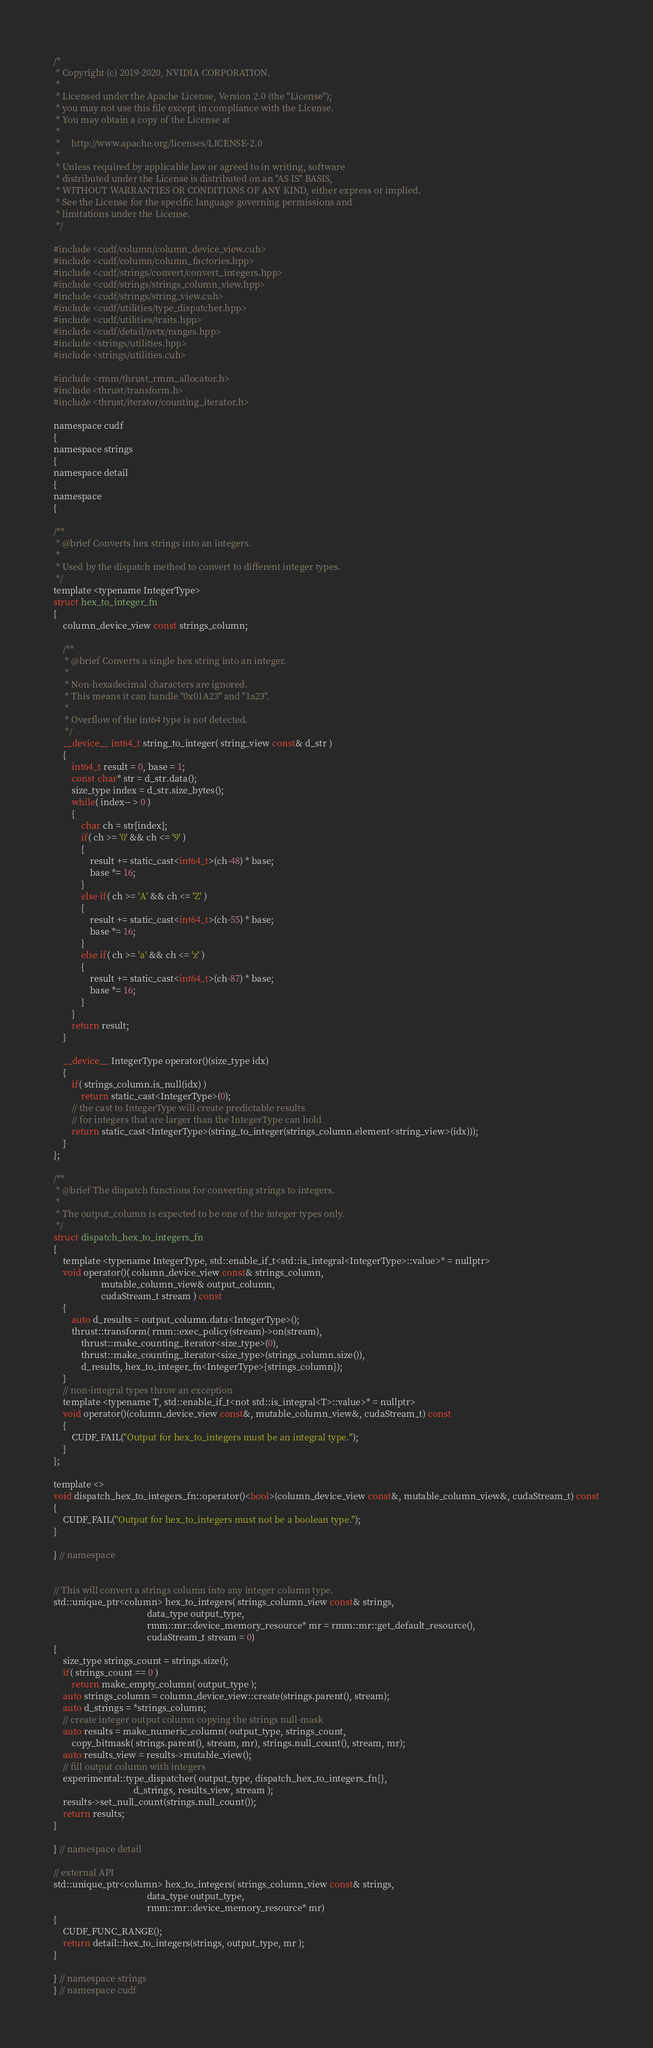<code> <loc_0><loc_0><loc_500><loc_500><_Cuda_>/*
 * Copyright (c) 2019-2020, NVIDIA CORPORATION.
 *
 * Licensed under the Apache License, Version 2.0 (the "License");
 * you may not use this file except in compliance with the License.
 * You may obtain a copy of the License at
 *
 *     http://www.apache.org/licenses/LICENSE-2.0
 *
 * Unless required by applicable law or agreed to in writing, software
 * distributed under the License is distributed on an "AS IS" BASIS,
 * WITHOUT WARRANTIES OR CONDITIONS OF ANY KIND, either express or implied.
 * See the License for the specific language governing permissions and
 * limitations under the License.
 */

#include <cudf/column/column_device_view.cuh>
#include <cudf/column/column_factories.hpp>
#include <cudf/strings/convert/convert_integers.hpp>
#include <cudf/strings/strings_column_view.hpp>
#include <cudf/strings/string_view.cuh>
#include <cudf/utilities/type_dispatcher.hpp>
#include <cudf/utilities/traits.hpp>
#include <cudf/detail/nvtx/ranges.hpp>
#include <strings/utilities.hpp>
#include <strings/utilities.cuh>

#include <rmm/thrust_rmm_allocator.h>
#include <thrust/transform.h>
#include <thrust/iterator/counting_iterator.h>

namespace cudf
{
namespace strings
{
namespace detail
{
namespace
{

/**
 * @brief Converts hex strings into an integers.
 *
 * Used by the dispatch method to convert to different integer types.
 */
template <typename IntegerType>
struct hex_to_integer_fn
{
    column_device_view const strings_column;

    /**
     * @brief Converts a single hex string into an integer.
     *
     * Non-hexadecimal characters are ignored.
     * This means it can handle "0x01A23" and "1a23".
     *
     * Overflow of the int64 type is not detected.
     */
    __device__ int64_t string_to_integer( string_view const& d_str )
    {
        int64_t result = 0, base = 1;
        const char* str = d_str.data();
        size_type index = d_str.size_bytes();
        while( index-- > 0 )
        {
            char ch = str[index];
            if( ch >= '0' && ch <= '9' )
            {
                result += static_cast<int64_t>(ch-48) * base;
                base *= 16;
            }
            else if( ch >= 'A' && ch <= 'Z' )
            {
                result += static_cast<int64_t>(ch-55) * base;
                base *= 16;
            }
            else if( ch >= 'a' && ch <= 'z' )
            {
                result += static_cast<int64_t>(ch-87) * base;
                base *= 16;
            }
        }
        return result;
    }

    __device__ IntegerType operator()(size_type idx)
    {
        if( strings_column.is_null(idx) )
            return static_cast<IntegerType>(0);
        // the cast to IntegerType will create predictable results
        // for integers that are larger than the IntegerType can hold
        return static_cast<IntegerType>(string_to_integer(strings_column.element<string_view>(idx)));
    }
};

/**
 * @brief The dispatch functions for converting strings to integers.
 *
 * The output_column is expected to be one of the integer types only.
 */
struct dispatch_hex_to_integers_fn
{
    template <typename IntegerType, std::enable_if_t<std::is_integral<IntegerType>::value>* = nullptr>
    void operator()( column_device_view const& strings_column,
                     mutable_column_view& output_column,
                     cudaStream_t stream ) const
    {
        auto d_results = output_column.data<IntegerType>();
        thrust::transform( rmm::exec_policy(stream)->on(stream),
            thrust::make_counting_iterator<size_type>(0),
            thrust::make_counting_iterator<size_type>(strings_column.size()),
            d_results, hex_to_integer_fn<IntegerType>{strings_column});
    }
    // non-integral types throw an exception
    template <typename T, std::enable_if_t<not std::is_integral<T>::value>* = nullptr>
    void operator()(column_device_view const&, mutable_column_view&, cudaStream_t) const
    {
        CUDF_FAIL("Output for hex_to_integers must be an integral type.");
    }
};

template <>
void dispatch_hex_to_integers_fn::operator()<bool>(column_device_view const&, mutable_column_view&, cudaStream_t) const
{
    CUDF_FAIL("Output for hex_to_integers must not be a boolean type.");
}

} // namespace


// This will convert a strings column into any integer column type.
std::unique_ptr<column> hex_to_integers( strings_column_view const& strings,
                                         data_type output_type,
                                         rmm::mr::device_memory_resource* mr = rmm::mr::get_default_resource(),
                                         cudaStream_t stream = 0)
{
    size_type strings_count = strings.size();
    if( strings_count == 0 )
        return make_empty_column( output_type );
    auto strings_column = column_device_view::create(strings.parent(), stream);
    auto d_strings = *strings_column;
    // create integer output column copying the strings null-mask
    auto results = make_numeric_column( output_type, strings_count,
        copy_bitmask( strings.parent(), stream, mr), strings.null_count(), stream, mr);
    auto results_view = results->mutable_view();
    // fill output column with integers
    experimental::type_dispatcher( output_type, dispatch_hex_to_integers_fn{},
                                   d_strings, results_view, stream );
    results->set_null_count(strings.null_count());
    return results;
}

} // namespace detail

// external API
std::unique_ptr<column> hex_to_integers( strings_column_view const& strings,
                                         data_type output_type,
                                         rmm::mr::device_memory_resource* mr)
{
    CUDF_FUNC_RANGE();
    return detail::hex_to_integers(strings, output_type, mr );
}

} // namespace strings
} // namespace cudf
</code> 